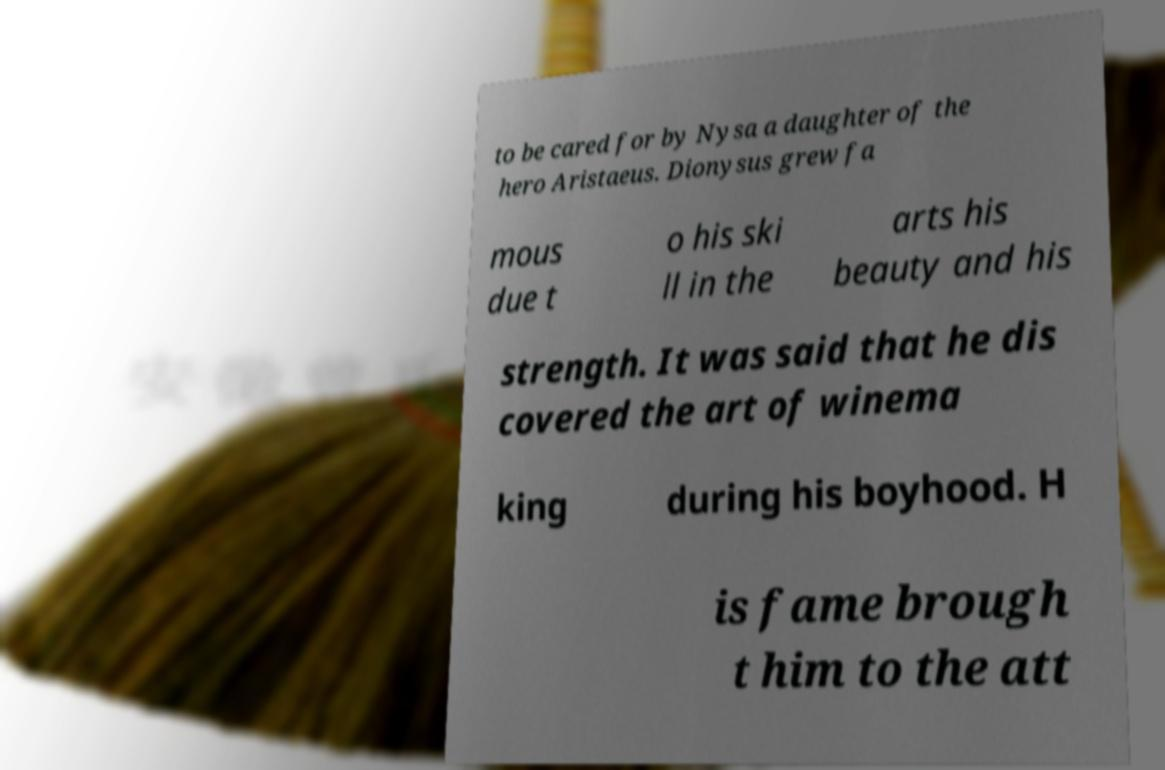Please read and relay the text visible in this image. What does it say? to be cared for by Nysa a daughter of the hero Aristaeus. Dionysus grew fa mous due t o his ski ll in the arts his beauty and his strength. It was said that he dis covered the art of winema king during his boyhood. H is fame brough t him to the att 